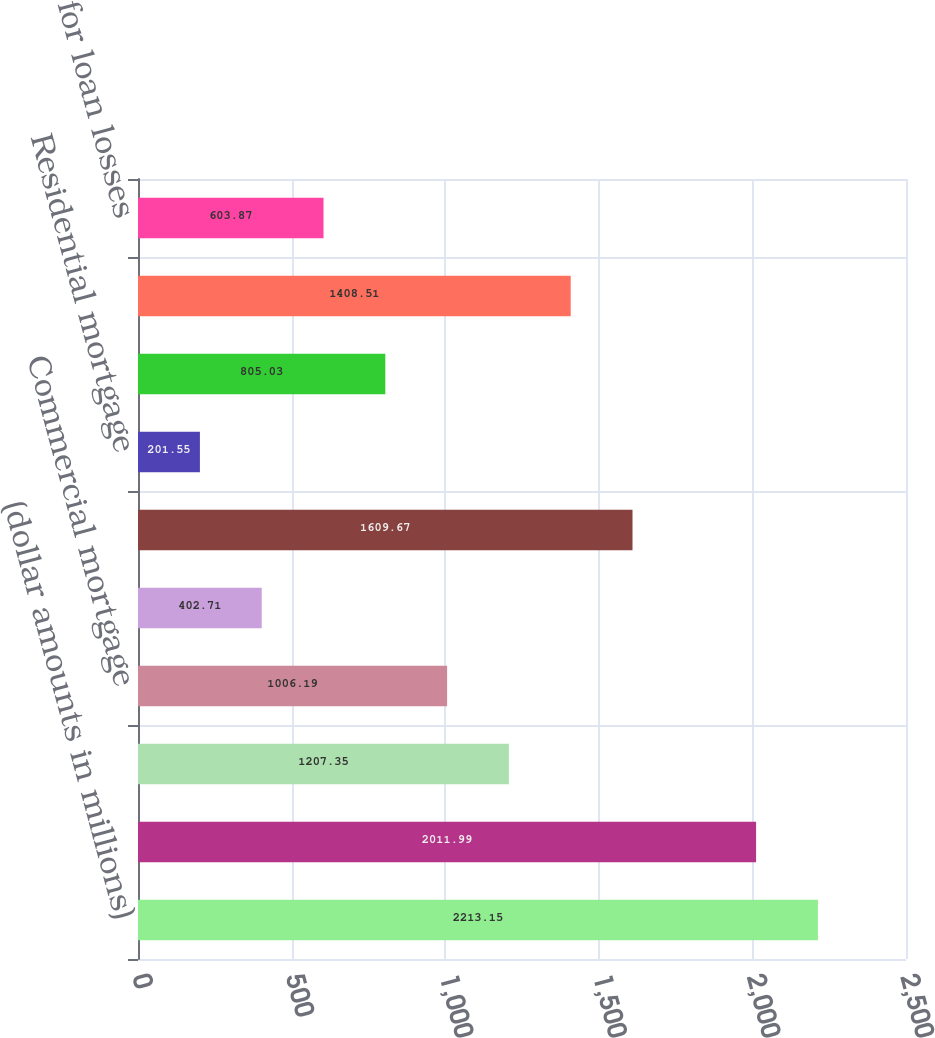Convert chart to OTSL. <chart><loc_0><loc_0><loc_500><loc_500><bar_chart><fcel>(dollar amounts in millions)<fcel>Balance at beginning of year<fcel>Commercial<fcel>Commercial mortgage<fcel>Consumer<fcel>Total loan charge-offs<fcel>Residential mortgage<fcel>Total recoveries<fcel>Net loan charge-offs<fcel>Provision for loan losses<nl><fcel>2213.15<fcel>2011.99<fcel>1207.35<fcel>1006.19<fcel>402.71<fcel>1609.67<fcel>201.55<fcel>805.03<fcel>1408.51<fcel>603.87<nl></chart> 